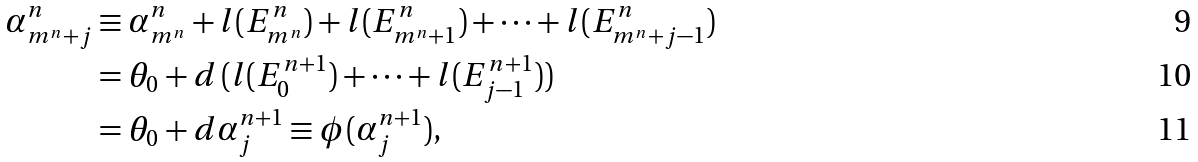<formula> <loc_0><loc_0><loc_500><loc_500>\alpha ^ { n } _ { m ^ { n } + j } & \equiv \alpha ^ { n } _ { m ^ { n } } + l ( E ^ { n } _ { m ^ { n } } ) + l ( E ^ { n } _ { m ^ { n } + 1 } ) + \dots + l ( E ^ { n } _ { m ^ { n } + j - 1 } ) \\ & = \theta _ { 0 } + d \, ( l ( E ^ { n + 1 } _ { 0 } ) + \dots + l ( E ^ { n + 1 } _ { j - 1 } ) ) \\ & = \theta _ { 0 } + d \alpha ^ { n + 1 } _ { j } \equiv \phi ( \alpha ^ { n + 1 } _ { j } ) ,</formula> 